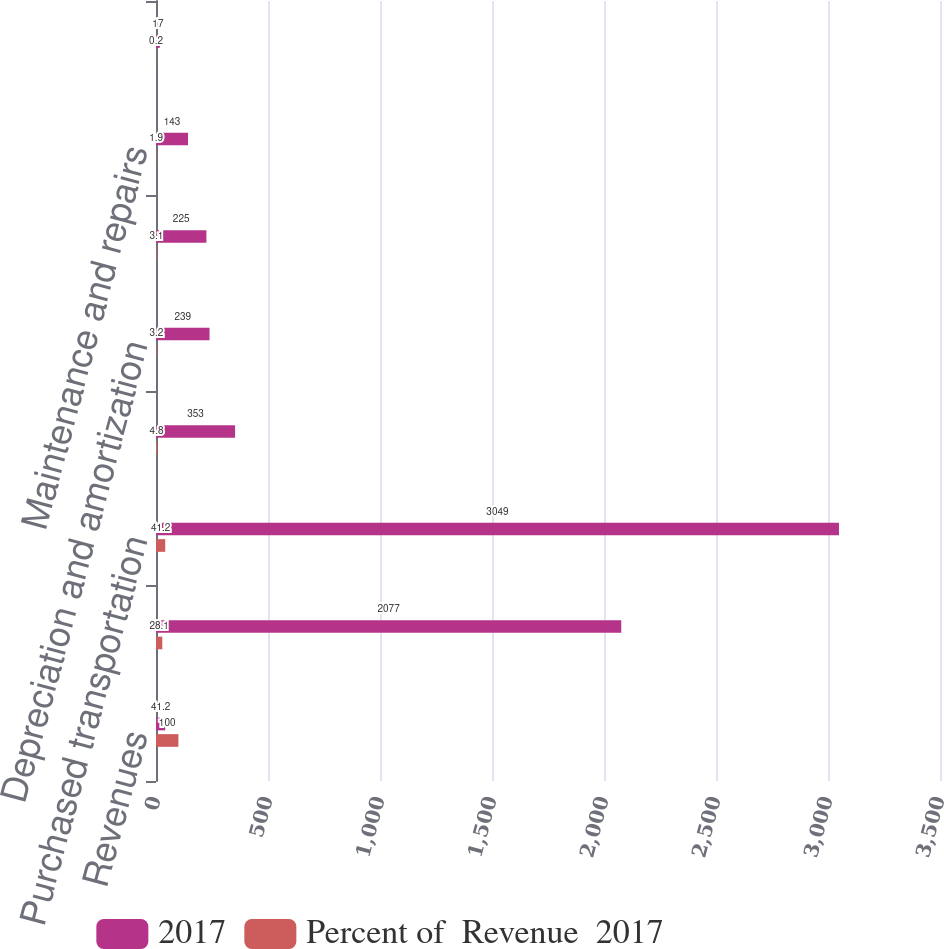Convert chart to OTSL. <chart><loc_0><loc_0><loc_500><loc_500><stacked_bar_chart><ecel><fcel>Revenues<fcel>Salaries and employee benefits<fcel>Purchased transportation<fcel>Rentals<fcel>Depreciation and amortization<fcel>Fuel<fcel>Maintenance and repairs<fcel>Intercompany charges<nl><fcel>2017<fcel>41.2<fcel>2077<fcel>3049<fcel>353<fcel>239<fcel>225<fcel>143<fcel>17<nl><fcel>Percent of  Revenue  2017<fcel>100<fcel>28.1<fcel>41.2<fcel>4.8<fcel>3.2<fcel>3.1<fcel>1.9<fcel>0.2<nl></chart> 